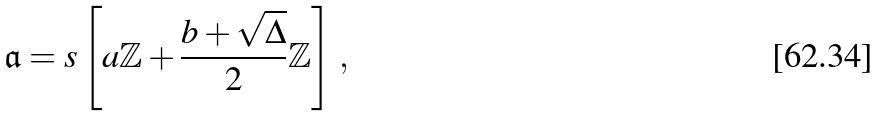<formula> <loc_0><loc_0><loc_500><loc_500>\mathfrak { a } = s \left [ a \mathbb { Z } + \frac { b + \sqrt { \Delta } } { 2 } \mathbb { Z } \right ] \, ,</formula> 